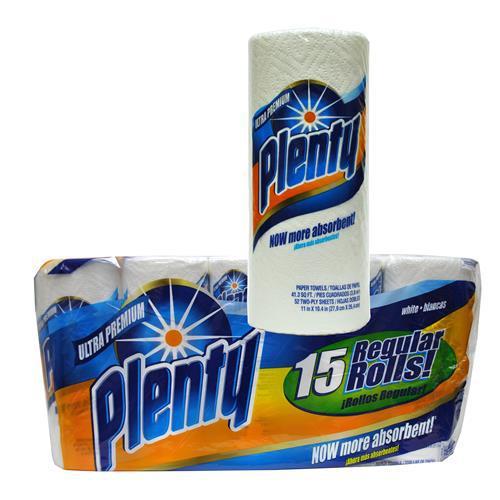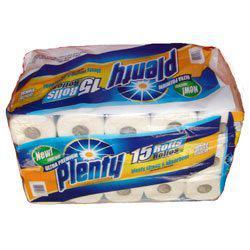The first image is the image on the left, the second image is the image on the right. Analyze the images presented: Is the assertion "The lefthand image contains one wrapped multi-roll of towels, and the right image shows one upright roll." valid? Answer yes or no. No. The first image is the image on the left, the second image is the image on the right. Examine the images to the left and right. Is the description "One picture shows one pack of paper towels, while the other shows only a single roll of paper towels." accurate? Answer yes or no. No. 